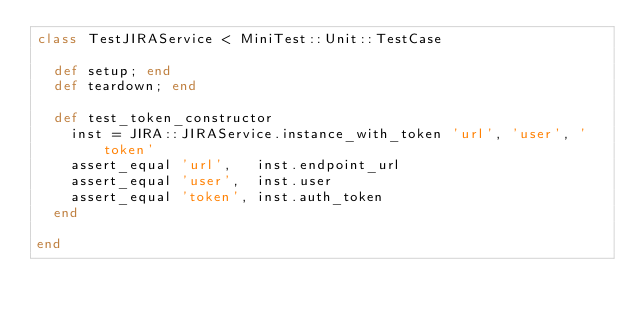<code> <loc_0><loc_0><loc_500><loc_500><_Ruby_>class TestJIRAService < MiniTest::Unit::TestCase

  def setup; end
  def teardown; end

  def test_token_constructor
    inst = JIRA::JIRAService.instance_with_token 'url', 'user', 'token'
    assert_equal 'url',   inst.endpoint_url
    assert_equal 'user',  inst.user
    assert_equal 'token', inst.auth_token
  end

end
</code> 